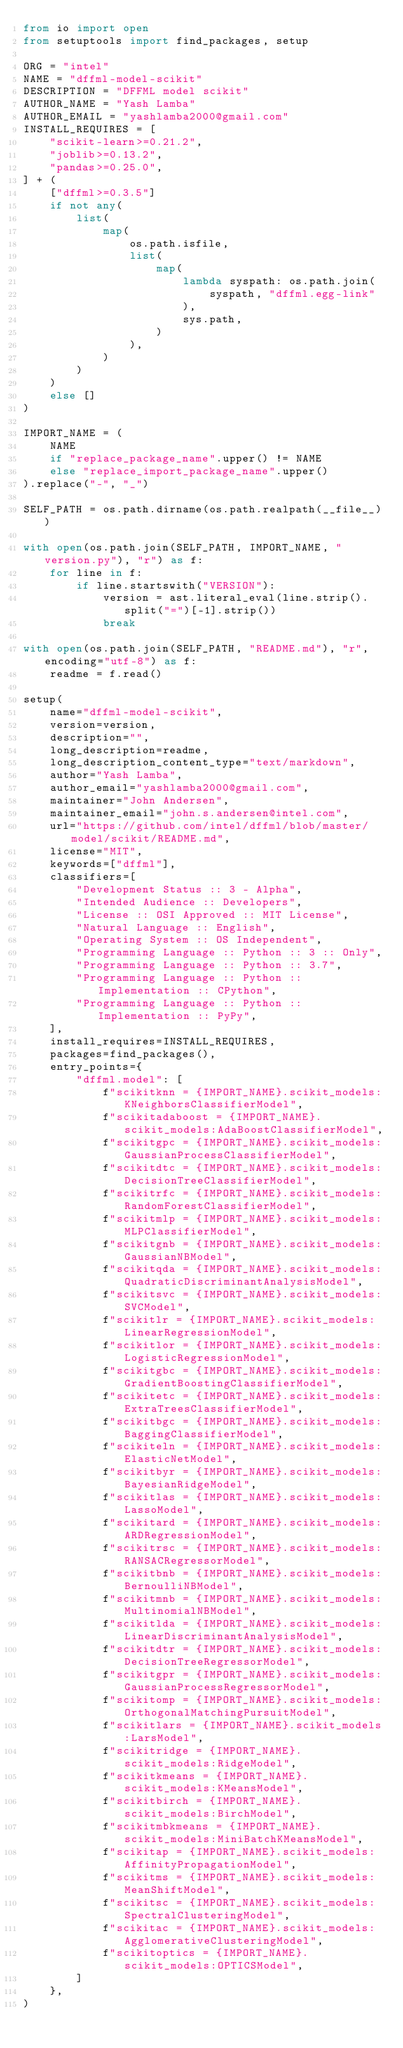Convert code to text. <code><loc_0><loc_0><loc_500><loc_500><_Python_>from io import open
from setuptools import find_packages, setup

ORG = "intel"
NAME = "dffml-model-scikit"
DESCRIPTION = "DFFML model scikit"
AUTHOR_NAME = "Yash Lamba"
AUTHOR_EMAIL = "yashlamba2000@gmail.com"
INSTALL_REQUIRES = [
    "scikit-learn>=0.21.2",
    "joblib>=0.13.2",
    "pandas>=0.25.0",
] + (
    ["dffml>=0.3.5"]
    if not any(
        list(
            map(
                os.path.isfile,
                list(
                    map(
                        lambda syspath: os.path.join(
                            syspath, "dffml.egg-link"
                        ),
                        sys.path,
                    )
                ),
            )
        )
    )
    else []
)

IMPORT_NAME = (
    NAME
    if "replace_package_name".upper() != NAME
    else "replace_import_package_name".upper()
).replace("-", "_")

SELF_PATH = os.path.dirname(os.path.realpath(__file__))

with open(os.path.join(SELF_PATH, IMPORT_NAME, "version.py"), "r") as f:
    for line in f:
        if line.startswith("VERSION"):
            version = ast.literal_eval(line.strip().split("=")[-1].strip())
            break

with open(os.path.join(SELF_PATH, "README.md"), "r", encoding="utf-8") as f:
    readme = f.read()

setup(
    name="dffml-model-scikit",
    version=version,
    description="",
    long_description=readme,
    long_description_content_type="text/markdown",
    author="Yash Lamba",
    author_email="yashlamba2000@gmail.com",
    maintainer="John Andersen",
    maintainer_email="john.s.andersen@intel.com",
    url="https://github.com/intel/dffml/blob/master/model/scikit/README.md",
    license="MIT",
    keywords=["dffml"],
    classifiers=[
        "Development Status :: 3 - Alpha",
        "Intended Audience :: Developers",
        "License :: OSI Approved :: MIT License",
        "Natural Language :: English",
        "Operating System :: OS Independent",
        "Programming Language :: Python :: 3 :: Only",
        "Programming Language :: Python :: 3.7",
        "Programming Language :: Python :: Implementation :: CPython",
        "Programming Language :: Python :: Implementation :: PyPy",
    ],
    install_requires=INSTALL_REQUIRES,
    packages=find_packages(),
    entry_points={
        "dffml.model": [
            f"scikitknn = {IMPORT_NAME}.scikit_models:KNeighborsClassifierModel",
            f"scikitadaboost = {IMPORT_NAME}.scikit_models:AdaBoostClassifierModel",
            f"scikitgpc = {IMPORT_NAME}.scikit_models:GaussianProcessClassifierModel",
            f"scikitdtc = {IMPORT_NAME}.scikit_models:DecisionTreeClassifierModel",
            f"scikitrfc = {IMPORT_NAME}.scikit_models:RandomForestClassifierModel",
            f"scikitmlp = {IMPORT_NAME}.scikit_models:MLPClassifierModel",
            f"scikitgnb = {IMPORT_NAME}.scikit_models:GaussianNBModel",
            f"scikitqda = {IMPORT_NAME}.scikit_models:QuadraticDiscriminantAnalysisModel",
            f"scikitsvc = {IMPORT_NAME}.scikit_models:SVCModel",
            f"scikitlr = {IMPORT_NAME}.scikit_models:LinearRegressionModel",
            f"scikitlor = {IMPORT_NAME}.scikit_models:LogisticRegressionModel",
            f"scikitgbc = {IMPORT_NAME}.scikit_models:GradientBoostingClassifierModel",
            f"scikitetc = {IMPORT_NAME}.scikit_models:ExtraTreesClassifierModel",
            f"scikitbgc = {IMPORT_NAME}.scikit_models:BaggingClassifierModel",
            f"scikiteln = {IMPORT_NAME}.scikit_models:ElasticNetModel",
            f"scikitbyr = {IMPORT_NAME}.scikit_models:BayesianRidgeModel",
            f"scikitlas = {IMPORT_NAME}.scikit_models:LassoModel",
            f"scikitard = {IMPORT_NAME}.scikit_models:ARDRegressionModel",
            f"scikitrsc = {IMPORT_NAME}.scikit_models:RANSACRegressorModel",
            f"scikitbnb = {IMPORT_NAME}.scikit_models:BernoulliNBModel",
            f"scikitmnb = {IMPORT_NAME}.scikit_models:MultinomialNBModel",
            f"scikitlda = {IMPORT_NAME}.scikit_models:LinearDiscriminantAnalysisModel",
            f"scikitdtr = {IMPORT_NAME}.scikit_models:DecisionTreeRegressorModel",
            f"scikitgpr = {IMPORT_NAME}.scikit_models:GaussianProcessRegressorModel",
            f"scikitomp = {IMPORT_NAME}.scikit_models:OrthogonalMatchingPursuitModel",
            f"scikitlars = {IMPORT_NAME}.scikit_models:LarsModel",
            f"scikitridge = {IMPORT_NAME}.scikit_models:RidgeModel",
            f"scikitkmeans = {IMPORT_NAME}.scikit_models:KMeansModel",
            f"scikitbirch = {IMPORT_NAME}.scikit_models:BirchModel",
            f"scikitmbkmeans = {IMPORT_NAME}.scikit_models:MiniBatchKMeansModel",
            f"scikitap = {IMPORT_NAME}.scikit_models:AffinityPropagationModel",
            f"scikitms = {IMPORT_NAME}.scikit_models:MeanShiftModel",
            f"scikitsc = {IMPORT_NAME}.scikit_models:SpectralClusteringModel",
            f"scikitac = {IMPORT_NAME}.scikit_models:AgglomerativeClusteringModel",
            f"scikitoptics = {IMPORT_NAME}.scikit_models:OPTICSModel",
        ]
    },
)
</code> 